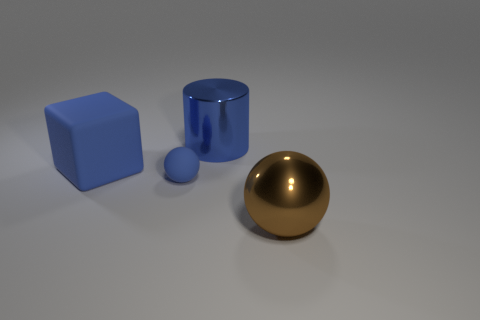Add 4 brown blocks. How many objects exist? 8 Subtract all blocks. How many objects are left? 3 Add 3 big green shiny cylinders. How many big green shiny cylinders exist? 3 Subtract 0 gray cylinders. How many objects are left? 4 Subtract all large brown objects. Subtract all blue objects. How many objects are left? 0 Add 2 big blue rubber objects. How many big blue rubber objects are left? 3 